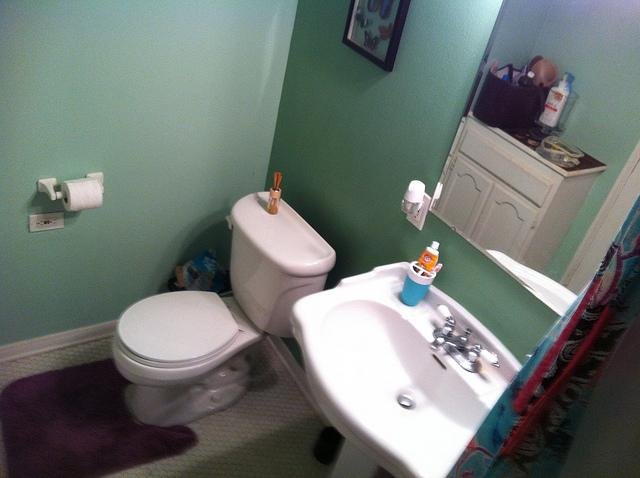What is likely in the large bottle in the reflection? Please explain your reasoning. lotion. The large bottle has lotion. 